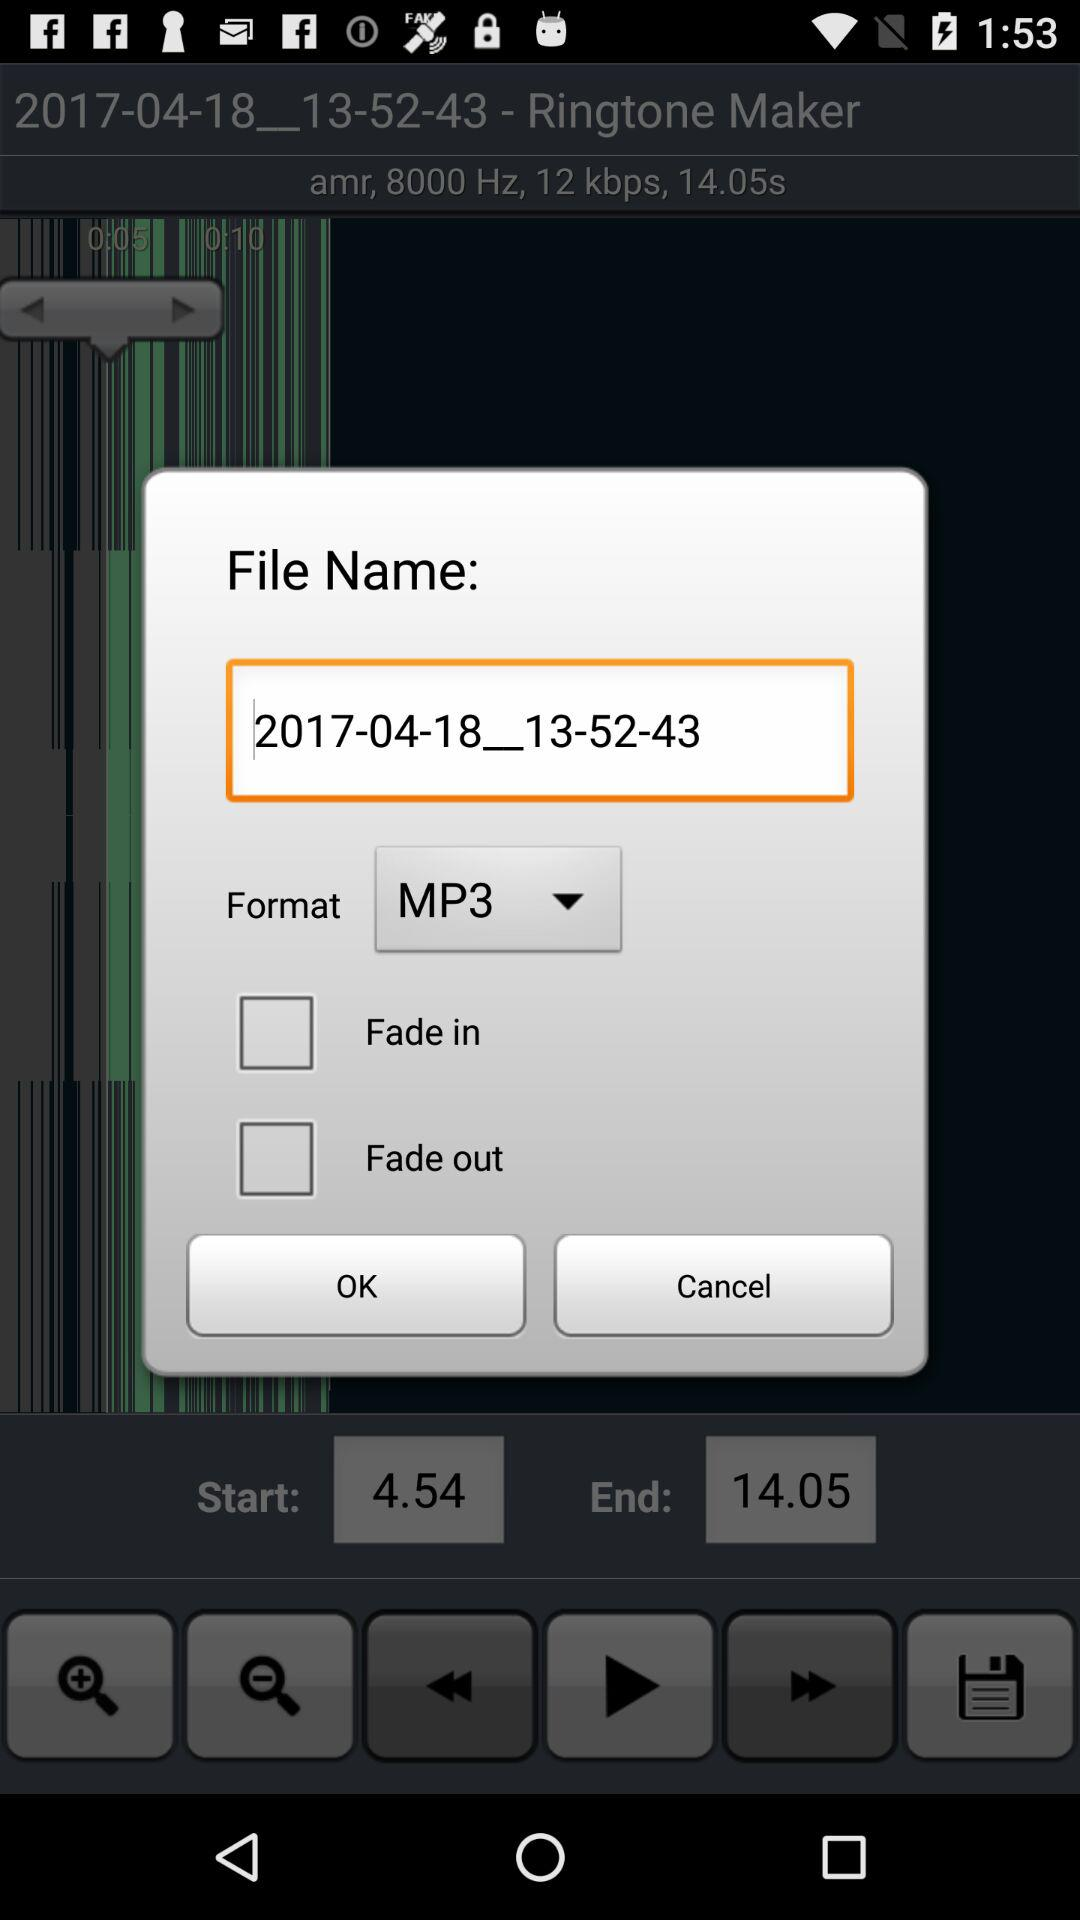What is the end time? The end time is 14.05. 